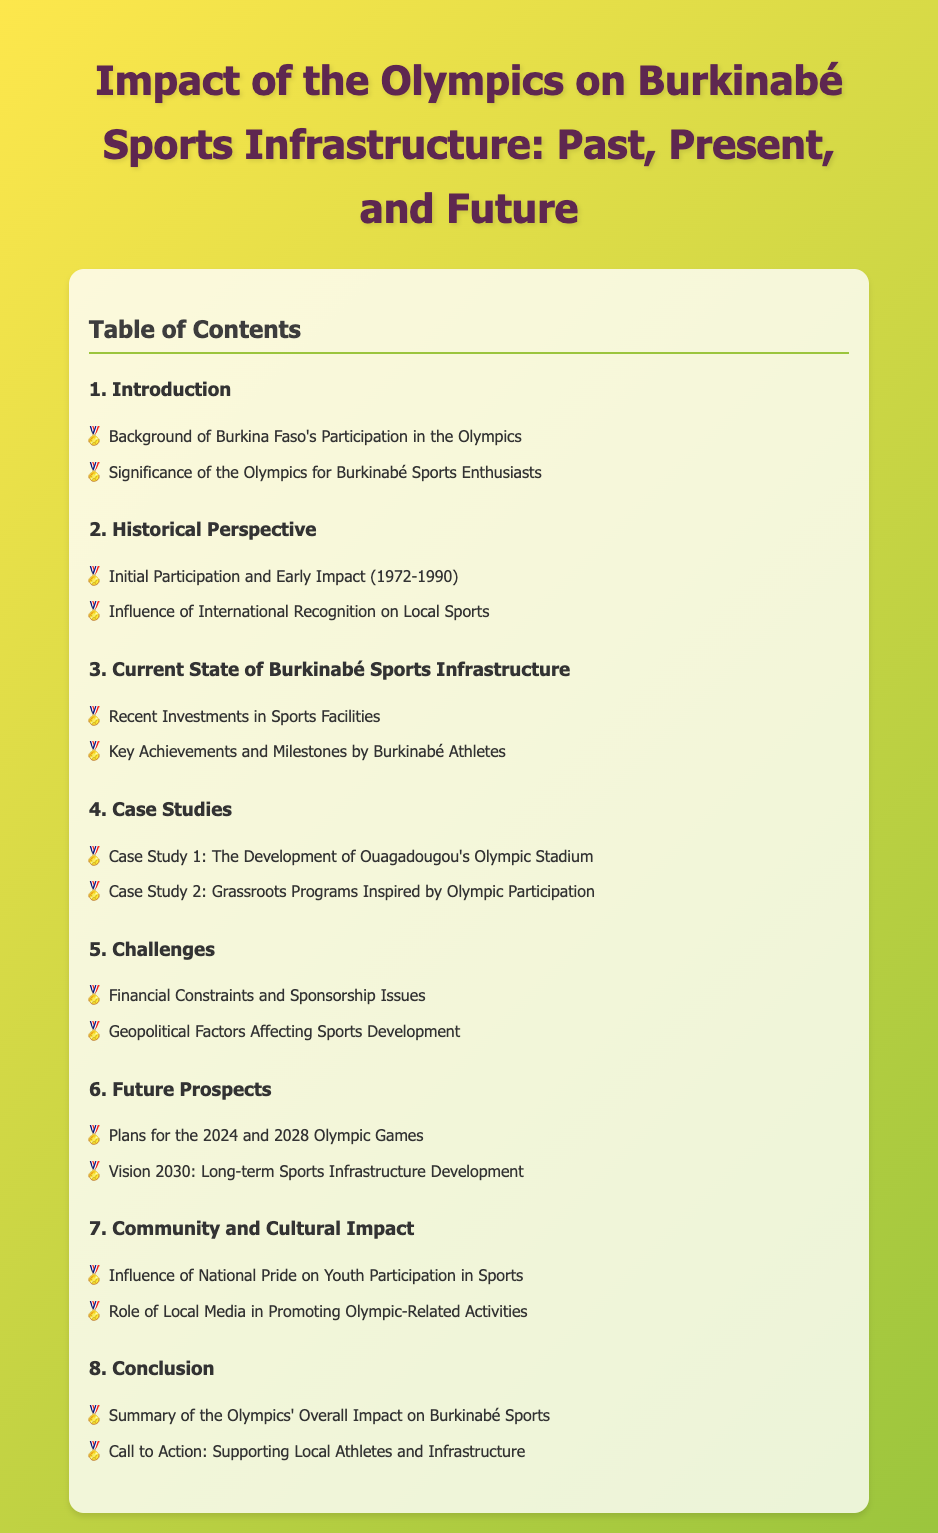What is the total number of main sections in the document? The total number of main sections can be counted in the Table of Contents, which lists 8 sections.
Answer: 8 What is the first case study mentioned? The document lists the case studies under the "Case Studies" section, where the first case study is "The Development of Ouagadougou's Olympic Stadium."
Answer: The Development of Ouagadougou's Olympic Stadium Which years are covered in the Historical Perspective section? The Historical Perspective section focuses on the years 1972 to 1990 in the first bullet point.
Answer: 1972-1990 What significant future event is mentioned in the Future Prospects section? The Future Prospects section highlights upcoming events, specifically mentioning the 2024 and 2028 Olympic Games.
Answer: 2024 and 2028 Olympic Games What role do local media play according to the Community and Cultural Impact section? The Community and Cultural Impact section indicates that local media promotes Olympic-related activities.
Answer: Promoting Olympic-related activities What is the final call to action in the document? The conclusion of the document includes a call to action for supporting local athletes and infrastructure.
Answer: Supporting Local Athletes and Infrastructure 